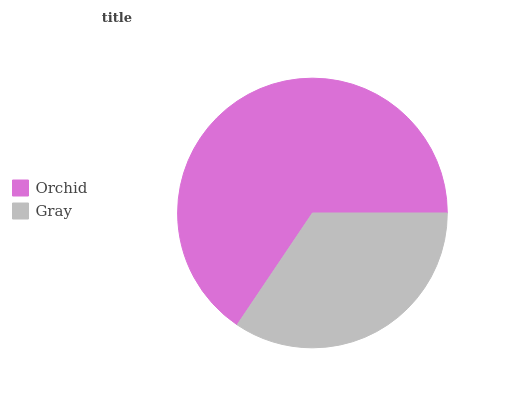Is Gray the minimum?
Answer yes or no. Yes. Is Orchid the maximum?
Answer yes or no. Yes. Is Gray the maximum?
Answer yes or no. No. Is Orchid greater than Gray?
Answer yes or no. Yes. Is Gray less than Orchid?
Answer yes or no. Yes. Is Gray greater than Orchid?
Answer yes or no. No. Is Orchid less than Gray?
Answer yes or no. No. Is Orchid the high median?
Answer yes or no. Yes. Is Gray the low median?
Answer yes or no. Yes. Is Gray the high median?
Answer yes or no. No. Is Orchid the low median?
Answer yes or no. No. 